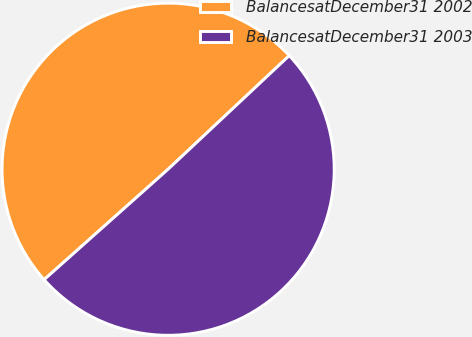<chart> <loc_0><loc_0><loc_500><loc_500><pie_chart><fcel>BalancesatDecember31 2002<fcel>BalancesatDecember31 2003<nl><fcel>49.59%<fcel>50.41%<nl></chart> 